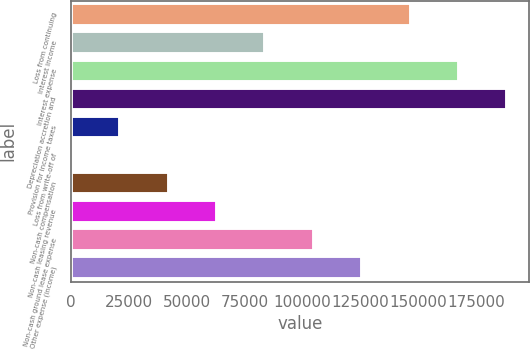Convert chart to OTSL. <chart><loc_0><loc_0><loc_500><loc_500><bar_chart><fcel>Loss from continuing<fcel>Interest income<fcel>Interest expense<fcel>Depreciation accretion and<fcel>Provision for income taxes<fcel>Loss from write-off of<fcel>Non-cash compensation<fcel>Non-cash leasing revenue<fcel>Non-cash ground lease expense<fcel>Other expense (income)<nl><fcel>146709<fcel>84018.2<fcel>167605<fcel>188502<fcel>21327.8<fcel>431<fcel>42224.6<fcel>63121.4<fcel>104915<fcel>125812<nl></chart> 